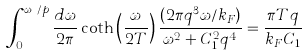<formula> <loc_0><loc_0><loc_500><loc_500>\int _ { 0 } ^ { \omega _ { c } / p } \frac { d \omega } { 2 \pi } \coth \left ( \frac { \omega } { 2 T } \right ) \frac { ( 2 \pi q ^ { 3 } \omega / k _ { F } ) } { \omega ^ { 2 } + C _ { 1 } ^ { 2 } q ^ { 4 } } = \frac { \pi T q } { k _ { F } C _ { 1 } }</formula> 